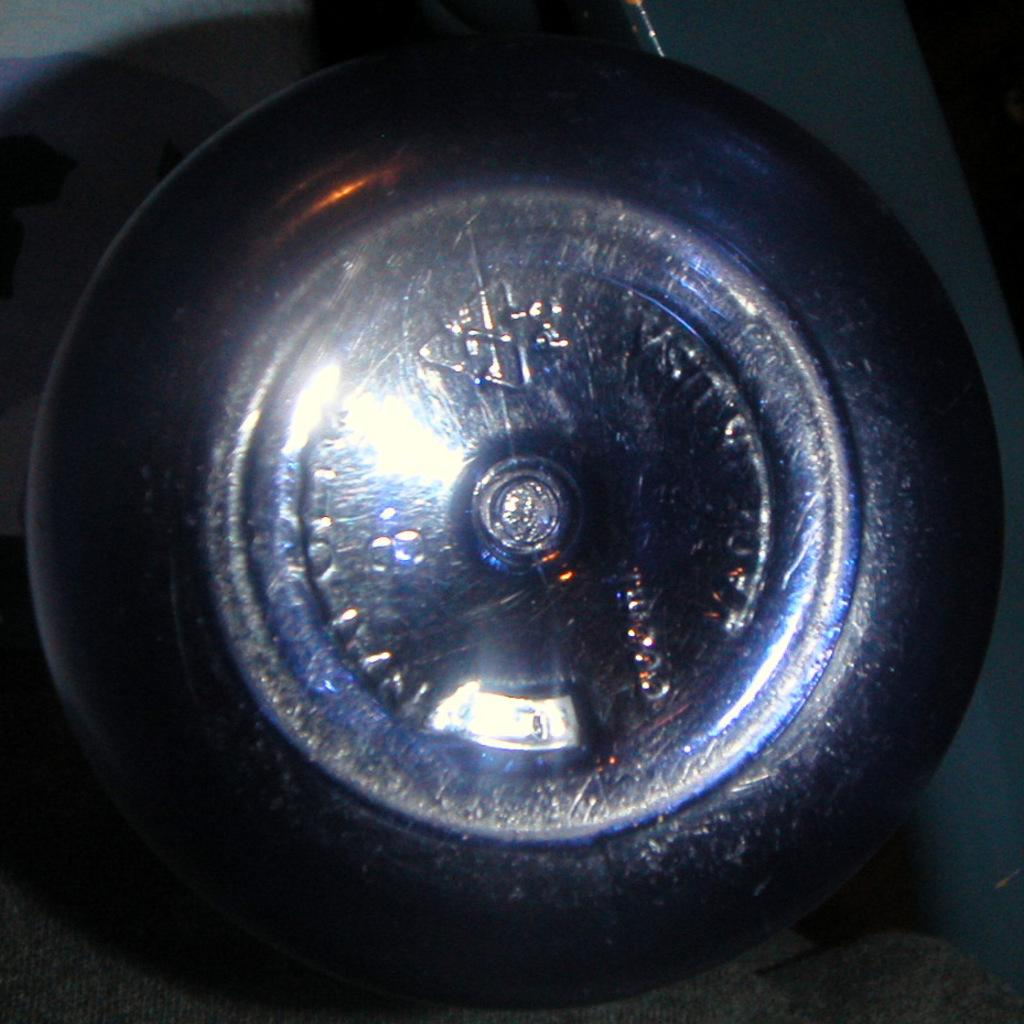What color is the tie in the image? The tie in the image is black. What is the material of the tie's pattern? The tie has an alloy pattern. Can you see a giraffe in the image? No, there is no giraffe present in the image. What type of animal is featured on the tie? The tie does not feature any animals; it has an alloy pattern. 